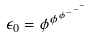<formula> <loc_0><loc_0><loc_500><loc_500>\epsilon _ { 0 } = \phi ^ { \phi ^ { \phi ^ { - ^ { - ^ { - } } } } }</formula> 